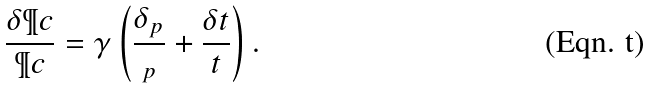<formula> <loc_0><loc_0><loc_500><loc_500>\frac { \delta \P c } { \P c } = \gamma \left ( \frac { \delta _ { p } } { _ { p } } + \frac { \delta t } { t } \right ) .</formula> 